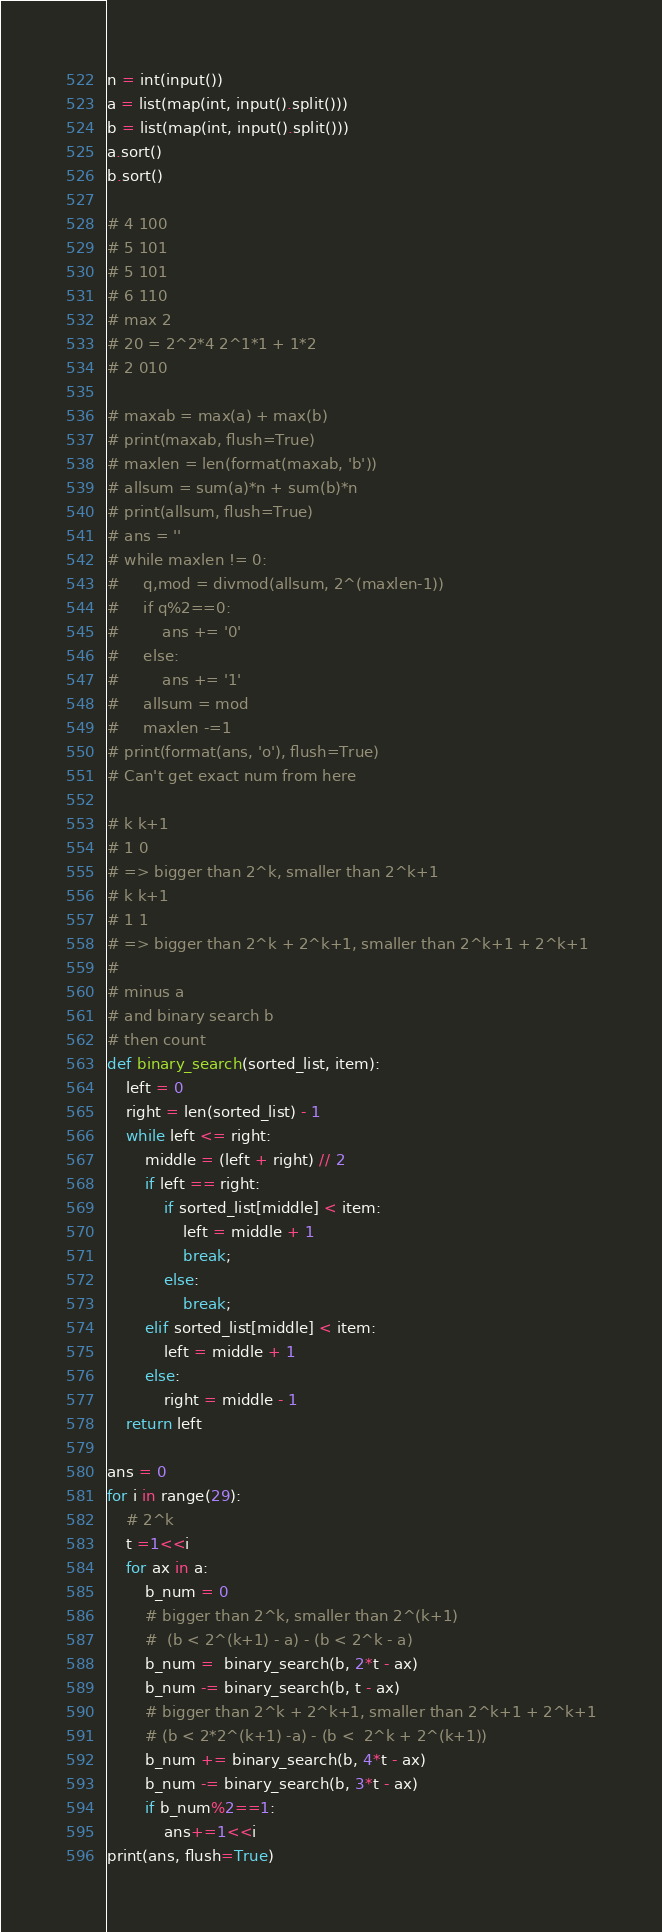Convert code to text. <code><loc_0><loc_0><loc_500><loc_500><_Python_>n = int(input())
a = list(map(int, input().split()))
b = list(map(int, input().split()))
a.sort()
b.sort()

# 4 100
# 5 101
# 5 101
# 6 110
# max 2
# 20 = 2^2*4 2^1*1 + 1*2
# 2 010

# maxab = max(a) + max(b)
# print(maxab, flush=True)
# maxlen = len(format(maxab, 'b'))
# allsum = sum(a)*n + sum(b)*n
# print(allsum, flush=True)
# ans = ''
# while maxlen != 0:
#     q,mod = divmod(allsum, 2^(maxlen-1))
#     if q%2==0:
#         ans += '0'
#     else:
#         ans += '1'
#     allsum = mod
#     maxlen -=1
# print(format(ans, 'o'), flush=True)
# Can't get exact num from here

# k k+1
# 1 0
# => bigger than 2^k, smaller than 2^k+1
# k k+1
# 1 1
# => bigger than 2^k + 2^k+1, smaller than 2^k+1 + 2^k+1
#
# minus a
# and binary search b
# then count
def binary_search(sorted_list, item):
    left = 0
    right = len(sorted_list) - 1
    while left <= right:
        middle = (left + right) // 2
        if left == right:
            if sorted_list[middle] < item:
                left = middle + 1
                break;
            else:
                break;
        elif sorted_list[middle] < item:
            left = middle + 1
        else:
            right = middle - 1
    return left

ans = 0
for i in range(29):
    # 2^k
    t =1<<i
    for ax in a:
        b_num = 0
        # bigger than 2^k, smaller than 2^(k+1)
        #  (b < 2^(k+1) - a) - (b < 2^k - a)
        b_num =  binary_search(b, 2*t - ax)
        b_num -= binary_search(b, t - ax)
        # bigger than 2^k + 2^k+1, smaller than 2^k+1 + 2^k+1
        # (b < 2*2^(k+1) -a) - (b <  2^k + 2^(k+1))
        b_num += binary_search(b, 4*t - ax)
        b_num -= binary_search(b, 3*t - ax)
        if b_num%2==1:
            ans+=1<<i
print(ans, flush=True)

</code> 